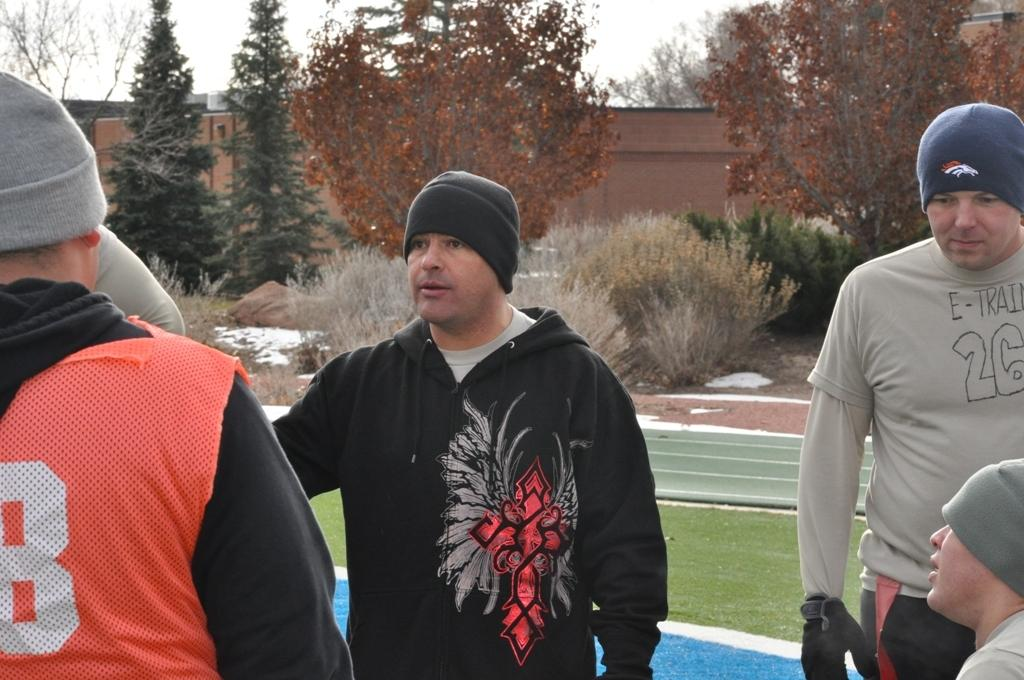What is the main subject of the image? The main subject of the image is a boy. Can you describe the boy's clothing in the image? The boy is wearing a black coat and a cap. What is visible at the top of the image? The sky is visible at the top of the image. What type of locket is the boy holding in the image? There is no locket present in the image; the boy is not holding anything. How does the boy control the things around him in the image? The boy is not controlling anything in the image; he is simply standing there. 